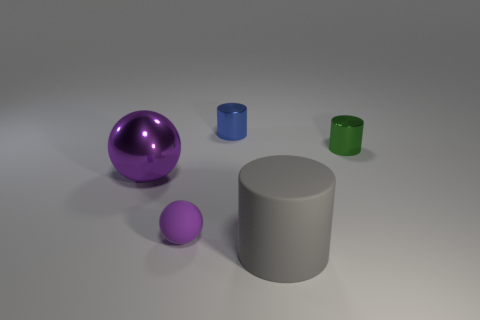There is a large thing to the right of the large purple metal object; what is its shape?
Give a very brief answer. Cylinder. How many big things have the same color as the small matte ball?
Provide a succinct answer. 1. What is the color of the rubber cylinder?
Offer a very short reply. Gray. There is a rubber thing that is on the right side of the tiny blue metallic cylinder; how many tiny metal objects are on the left side of it?
Your answer should be very brief. 1. There is a blue cylinder; is it the same size as the shiny cylinder that is on the right side of the big gray cylinder?
Your answer should be compact. Yes. Does the green metallic object have the same size as the matte sphere?
Keep it short and to the point. Yes. Is there a blue matte block of the same size as the blue metallic cylinder?
Give a very brief answer. No. There is a small cylinder that is to the right of the large gray object; what is it made of?
Ensure brevity in your answer.  Metal. There is a small thing that is the same material as the small green cylinder; what color is it?
Your response must be concise. Blue. What number of matte objects are either large cyan spheres or large balls?
Offer a terse response. 0. 